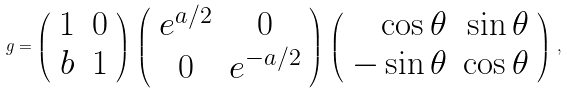Convert formula to latex. <formula><loc_0><loc_0><loc_500><loc_500>g = \left ( \begin{array} { c c } { 1 } & { 0 } \\ { b } & { 1 } \end{array} \right ) \, \left ( \begin{array} { c c } { { e ^ { a / 2 } } } & { 0 } \\ { 0 } & { { e ^ { - a / 2 } } } \end{array} \right ) \, \left ( \begin{array} { r r } { \cos \theta } & { \sin \theta } \\ { - \sin \theta } & { \cos \theta } \end{array} \right ) \, ,</formula> 